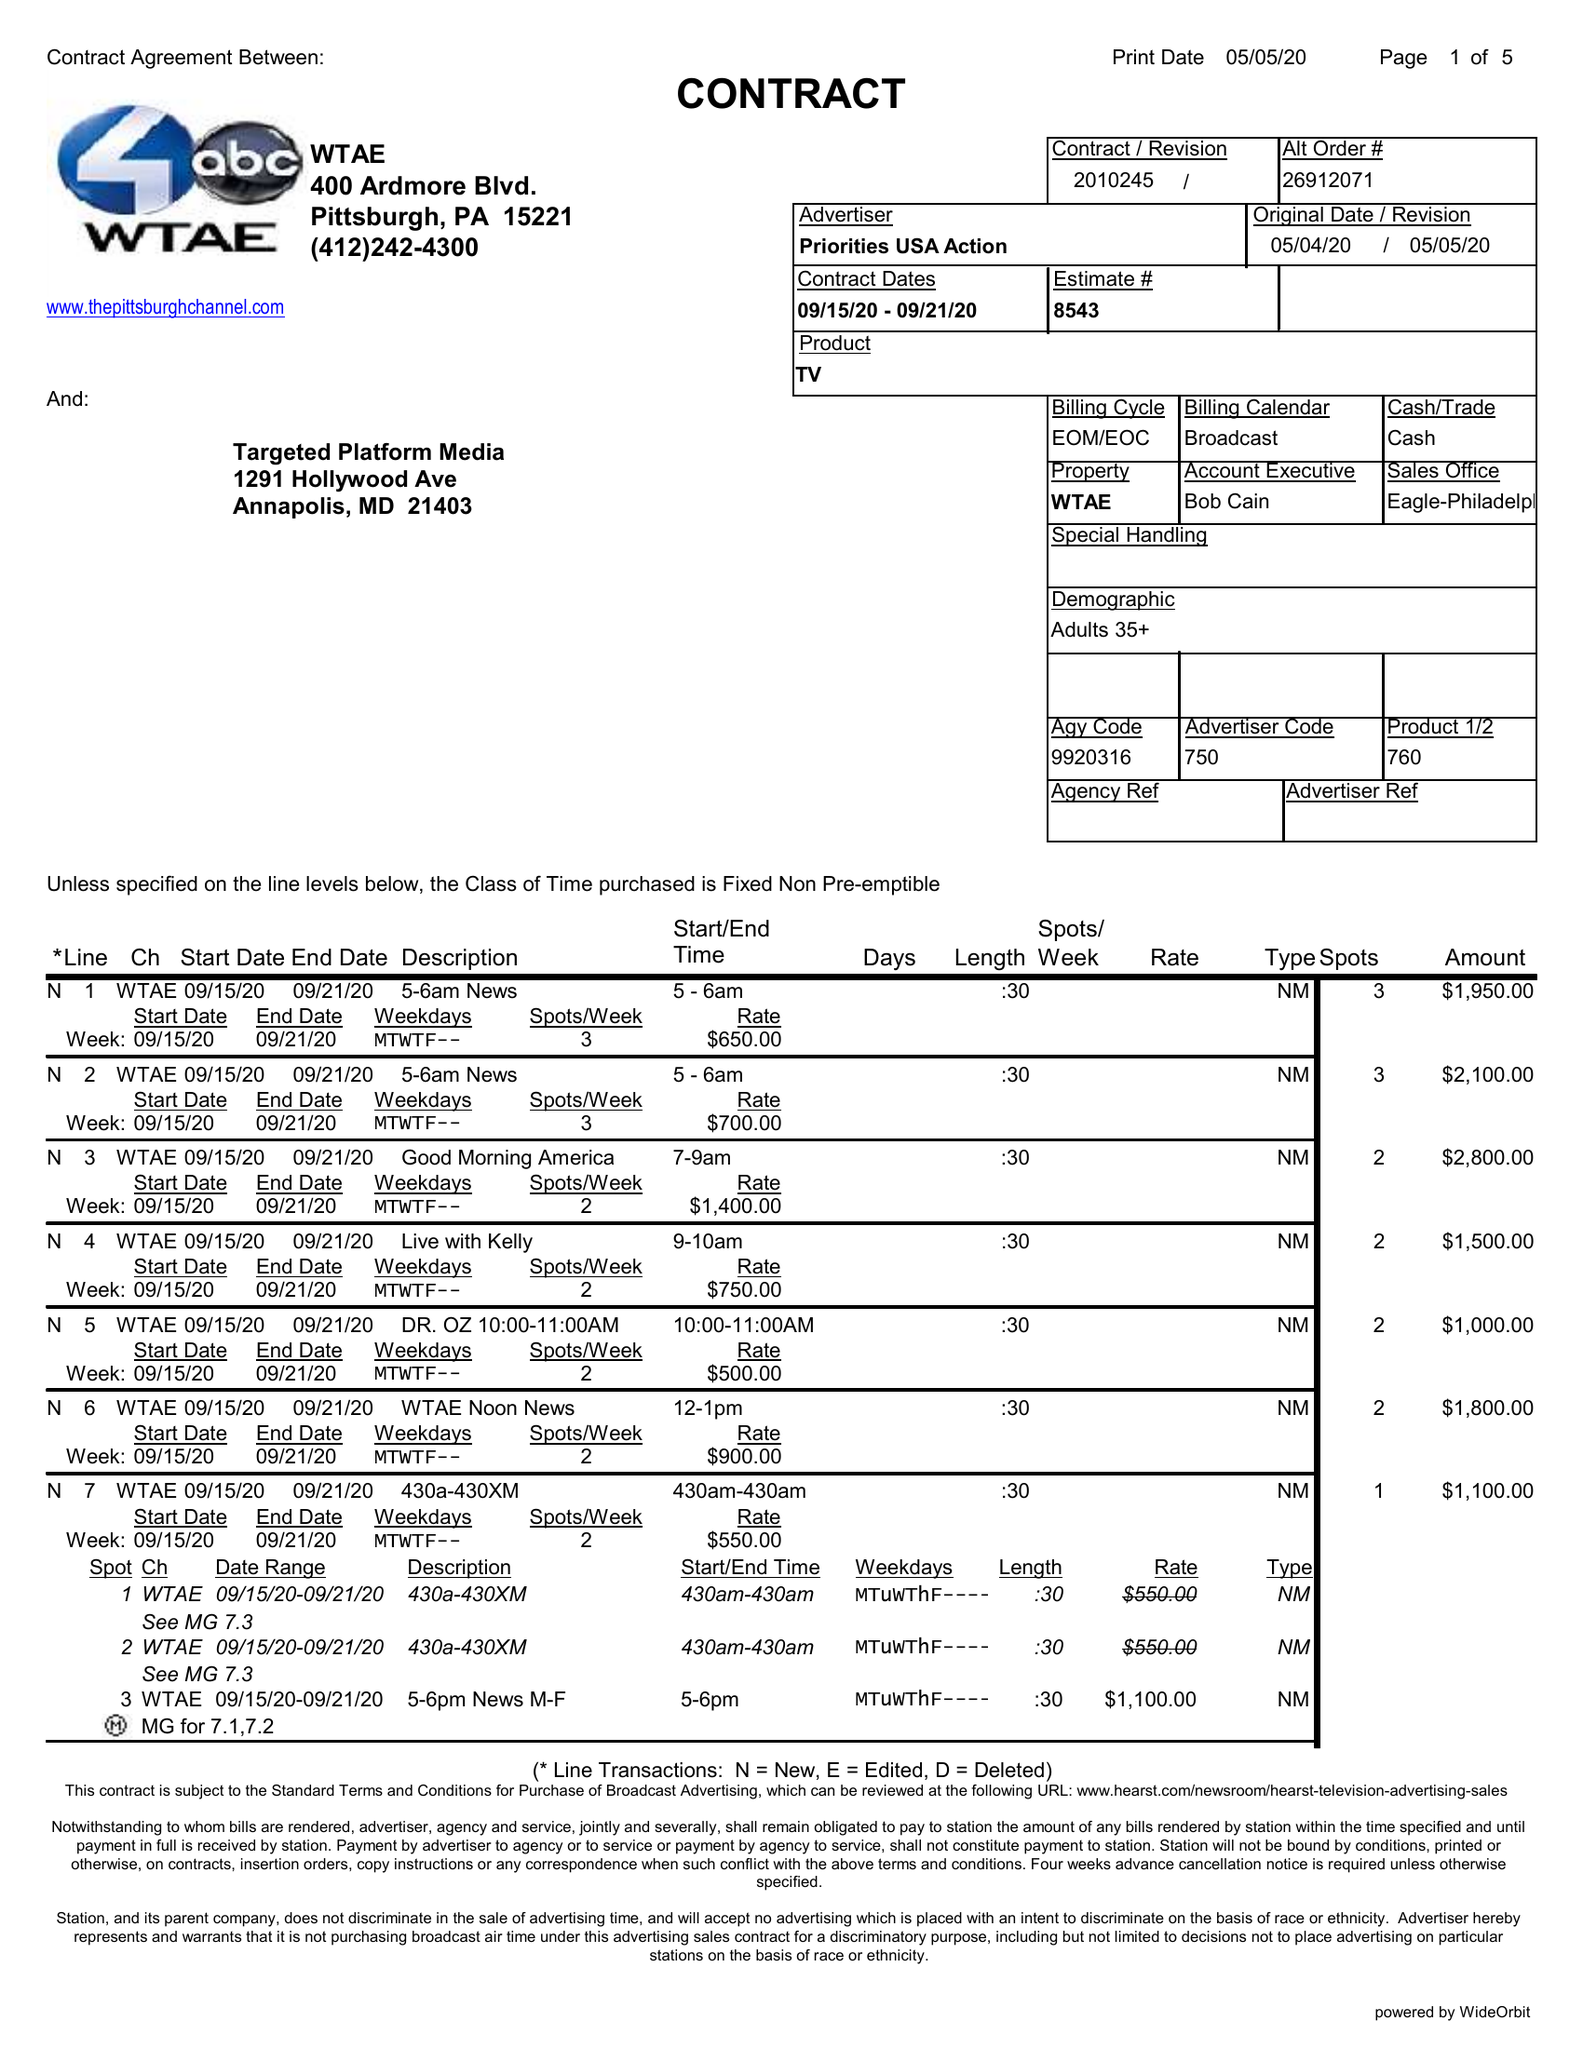What is the value for the flight_to?
Answer the question using a single word or phrase. 09/21/20 